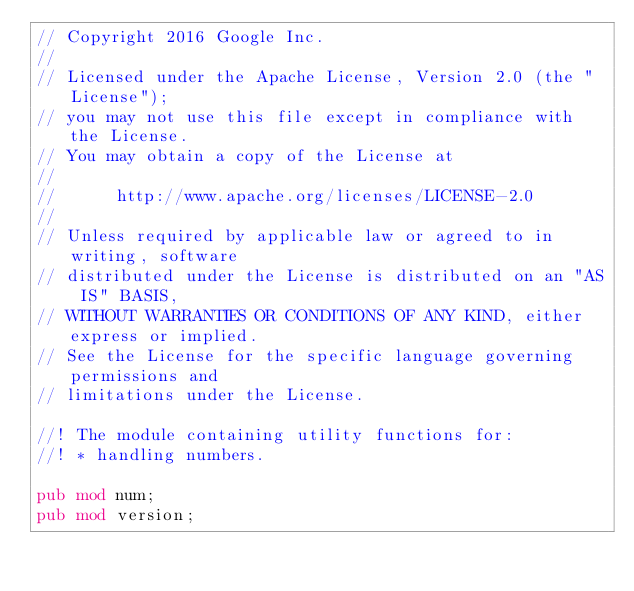<code> <loc_0><loc_0><loc_500><loc_500><_Rust_>// Copyright 2016 Google Inc.
//
// Licensed under the Apache License, Version 2.0 (the "License");
// you may not use this file except in compliance with the License.
// You may obtain a copy of the License at
//
//      http://www.apache.org/licenses/LICENSE-2.0
//
// Unless required by applicable law or agreed to in writing, software
// distributed under the License is distributed on an "AS IS" BASIS,
// WITHOUT WARRANTIES OR CONDITIONS OF ANY KIND, either express or implied.
// See the License for the specific language governing permissions and
// limitations under the License.

//! The module containing utility functions for:
//! * handling numbers.

pub mod num;
pub mod version;
</code> 